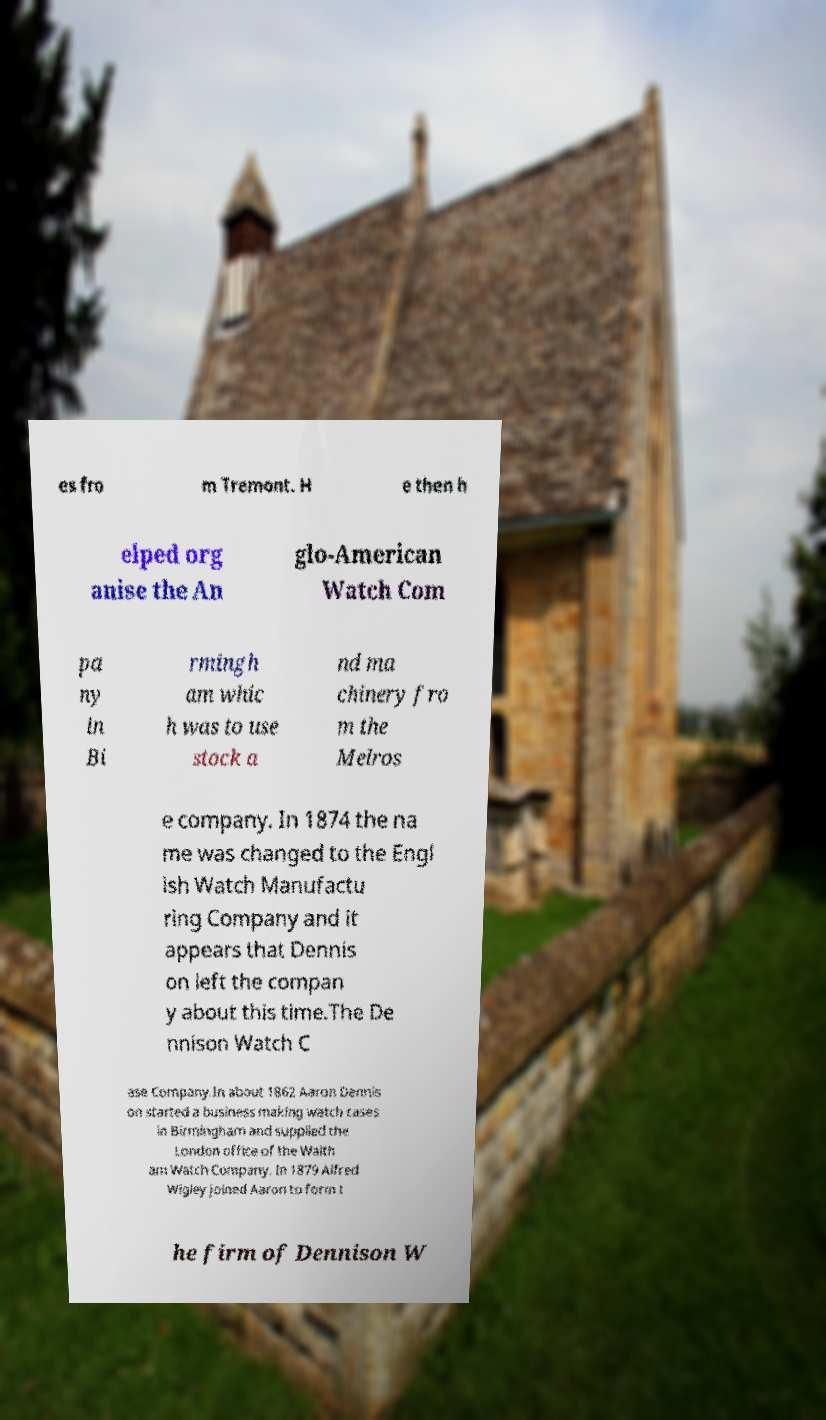Could you extract and type out the text from this image? es fro m Tremont. H e then h elped org anise the An glo-American Watch Com pa ny in Bi rmingh am whic h was to use stock a nd ma chinery fro m the Melros e company. In 1874 the na me was changed to the Engl ish Watch Manufactu ring Company and it appears that Dennis on left the compan y about this time.The De nnison Watch C ase Company.In about 1862 Aaron Dennis on started a business making watch cases in Birmingham and supplied the London office of the Walth am Watch Company. In 1879 Alfred Wigley joined Aaron to form t he firm of Dennison W 